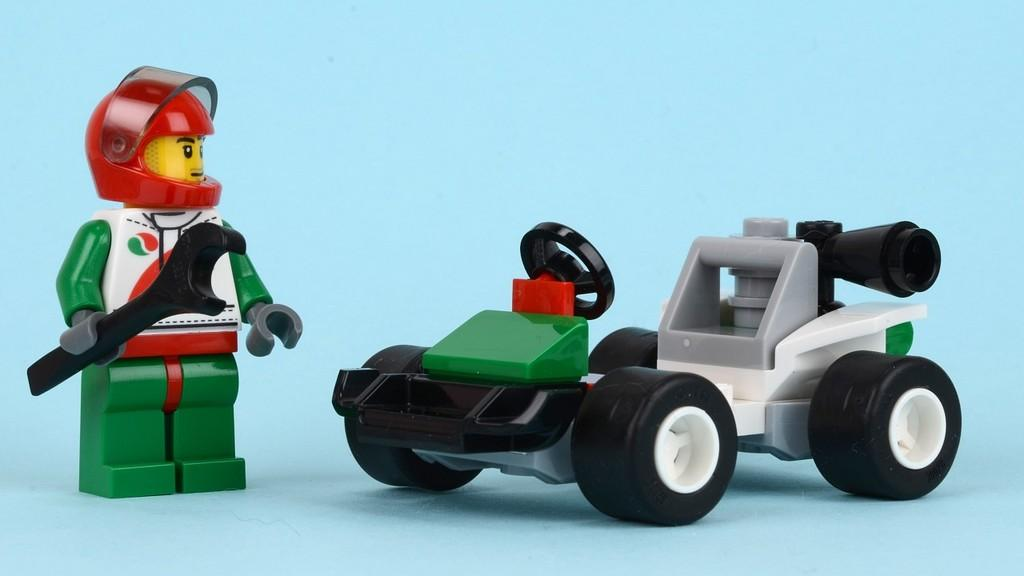How many toys can be seen in the image? There are two toys in the image. What color is the background of the image? The background of the image is blue. What type of leaf is falling on the toys in the image? There are no leaves present in the image; it only features two toys against a blue background. 